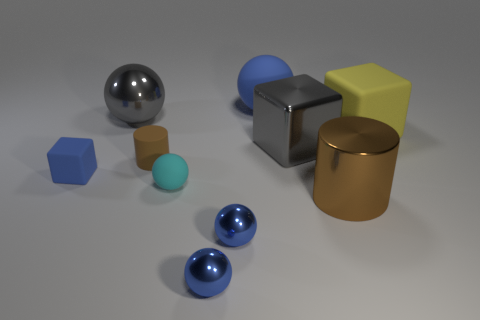Subtract all yellow cylinders. How many blue spheres are left? 3 Subtract 2 balls. How many balls are left? 3 Subtract all gray balls. How many balls are left? 4 Subtract all gray balls. How many balls are left? 4 Subtract all red spheres. Subtract all yellow cylinders. How many spheres are left? 5 Subtract all cylinders. How many objects are left? 8 Subtract all large yellow blocks. Subtract all large metallic cylinders. How many objects are left? 8 Add 2 big gray shiny balls. How many big gray shiny balls are left? 3 Add 3 brown rubber spheres. How many brown rubber spheres exist? 3 Subtract 0 purple cylinders. How many objects are left? 10 